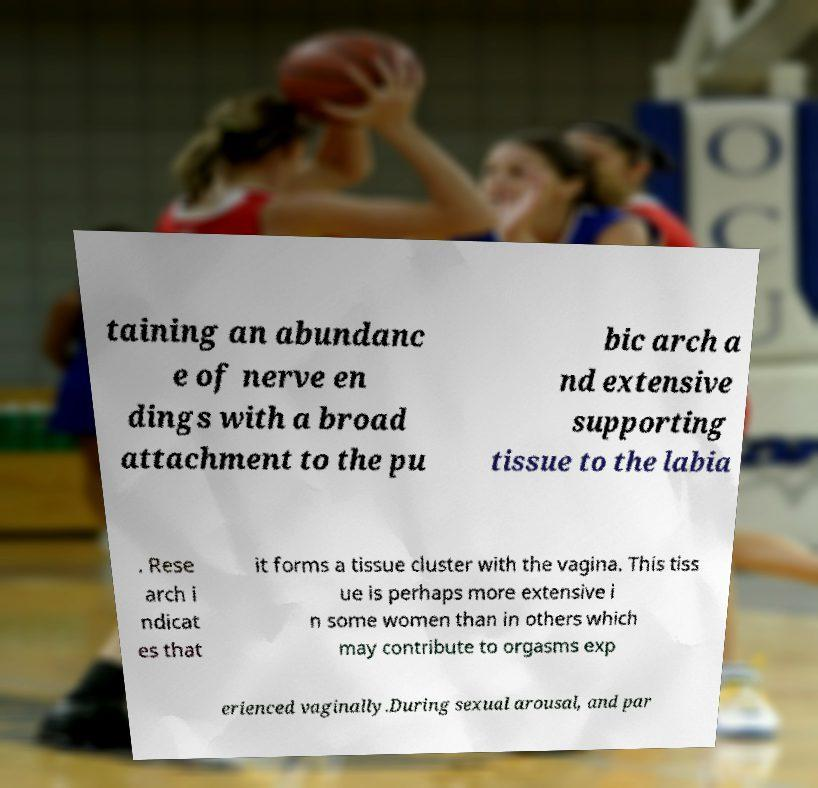Can you accurately transcribe the text from the provided image for me? taining an abundanc e of nerve en dings with a broad attachment to the pu bic arch a nd extensive supporting tissue to the labia . Rese arch i ndicat es that it forms a tissue cluster with the vagina. This tiss ue is perhaps more extensive i n some women than in others which may contribute to orgasms exp erienced vaginally.During sexual arousal, and par 